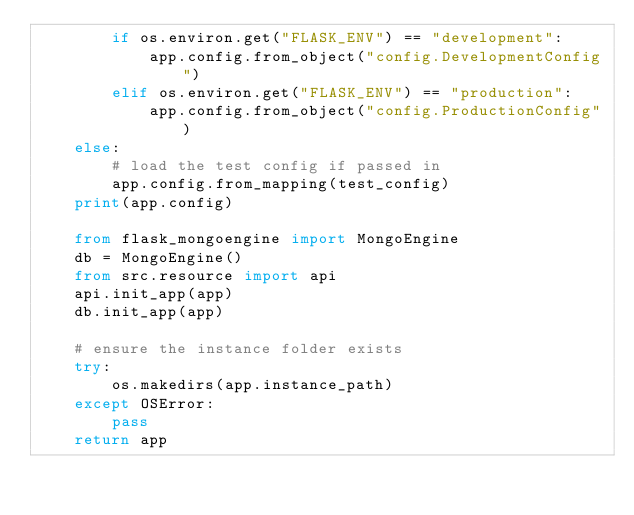<code> <loc_0><loc_0><loc_500><loc_500><_Python_>        if os.environ.get("FLASK_ENV") == "development":
            app.config.from_object("config.DevelopmentConfig")
        elif os.environ.get("FLASK_ENV") == "production":
            app.config.from_object("config.ProductionConfig")
    else:
        # load the test config if passed in
        app.config.from_mapping(test_config)
    print(app.config)

    from flask_mongoengine import MongoEngine
    db = MongoEngine()
    from src.resource import api
    api.init_app(app)
    db.init_app(app)

    # ensure the instance folder exists
    try:
        os.makedirs(app.instance_path)
    except OSError:
        pass
    return app
</code> 